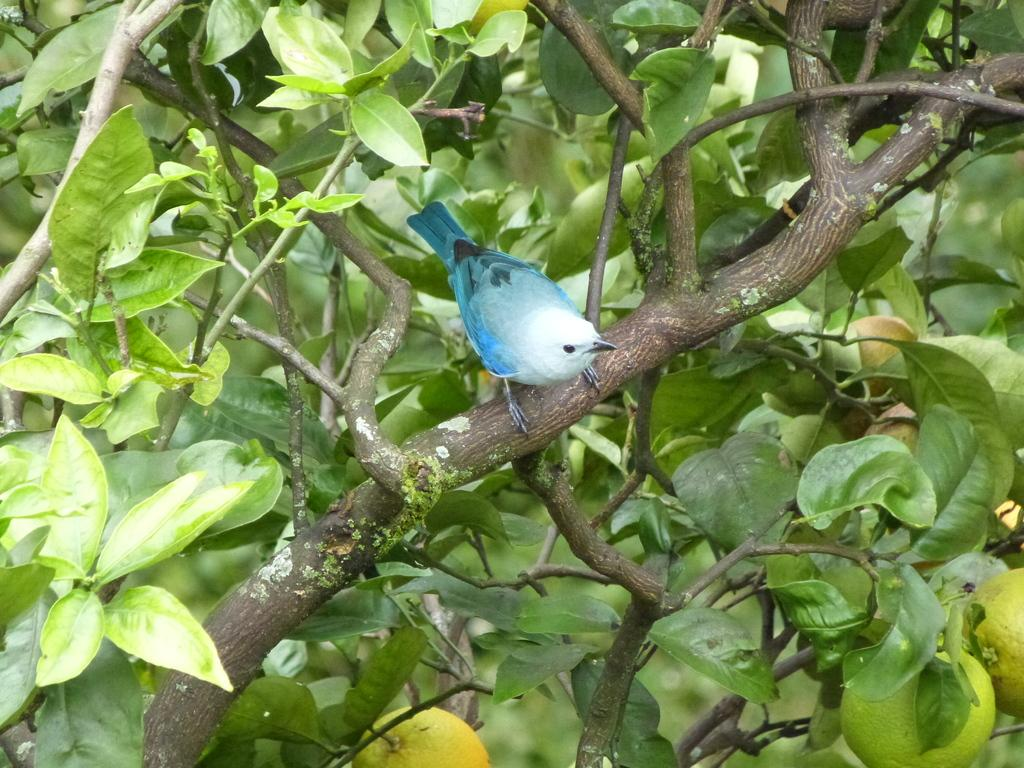What type of animal is in the image? There is a blue color bird in the image. Where is the bird located in the image? The bird is standing on a branch of a tree. What type of yam is growing near the bird in the image? There is no yam present in the image; it features a blue color bird standing on a branch of a tree. Can you tell me where the church is located in the image? There is no church present in the image. 